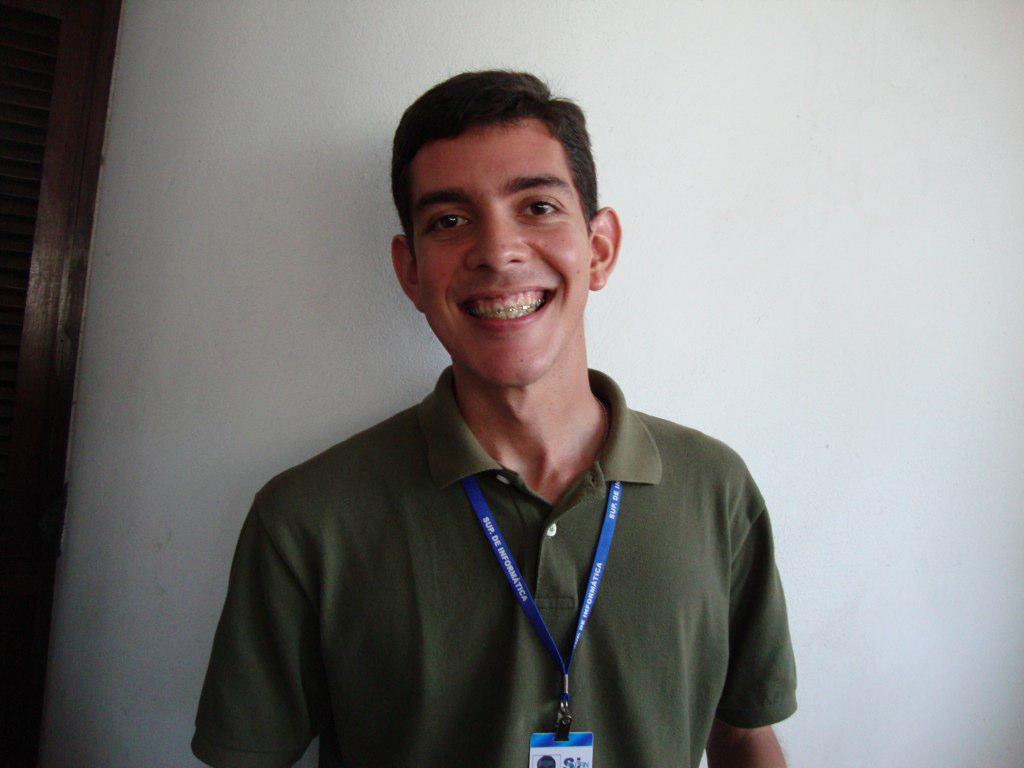Could you give a brief overview of what you see in this image? In this image we can see a person. 